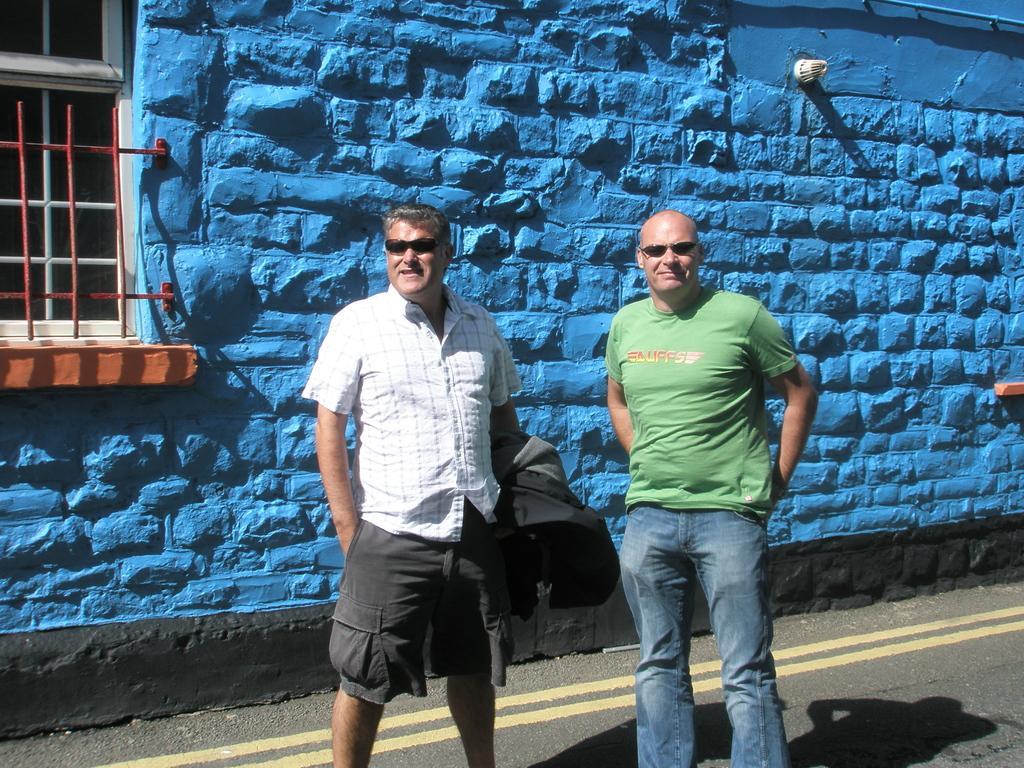Can you describe this image briefly? There are two men standing and smiling. They wore goggles. This man is holding a jacket in his hand. I think this is a building with a window. This wall is blue in color. I can see the shadow of two men on the road. 